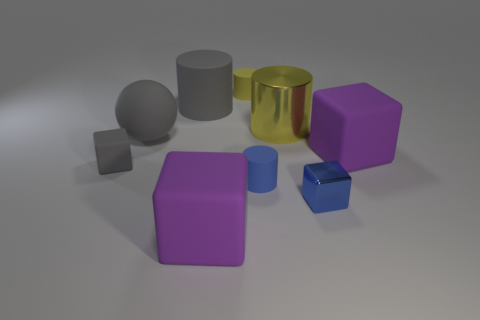Subtract all red blocks. How many yellow cylinders are left? 2 Subtract 2 cubes. How many cubes are left? 2 Subtract all blue cylinders. How many cylinders are left? 3 Subtract all blue cylinders. How many cylinders are left? 3 Add 1 small red rubber objects. How many objects exist? 10 Subtract all cylinders. How many objects are left? 5 Subtract all cyan cylinders. Subtract all green balls. How many cylinders are left? 4 Add 4 big spheres. How many big spheres are left? 5 Add 7 big blue balls. How many big blue balls exist? 7 Subtract 0 purple cylinders. How many objects are left? 9 